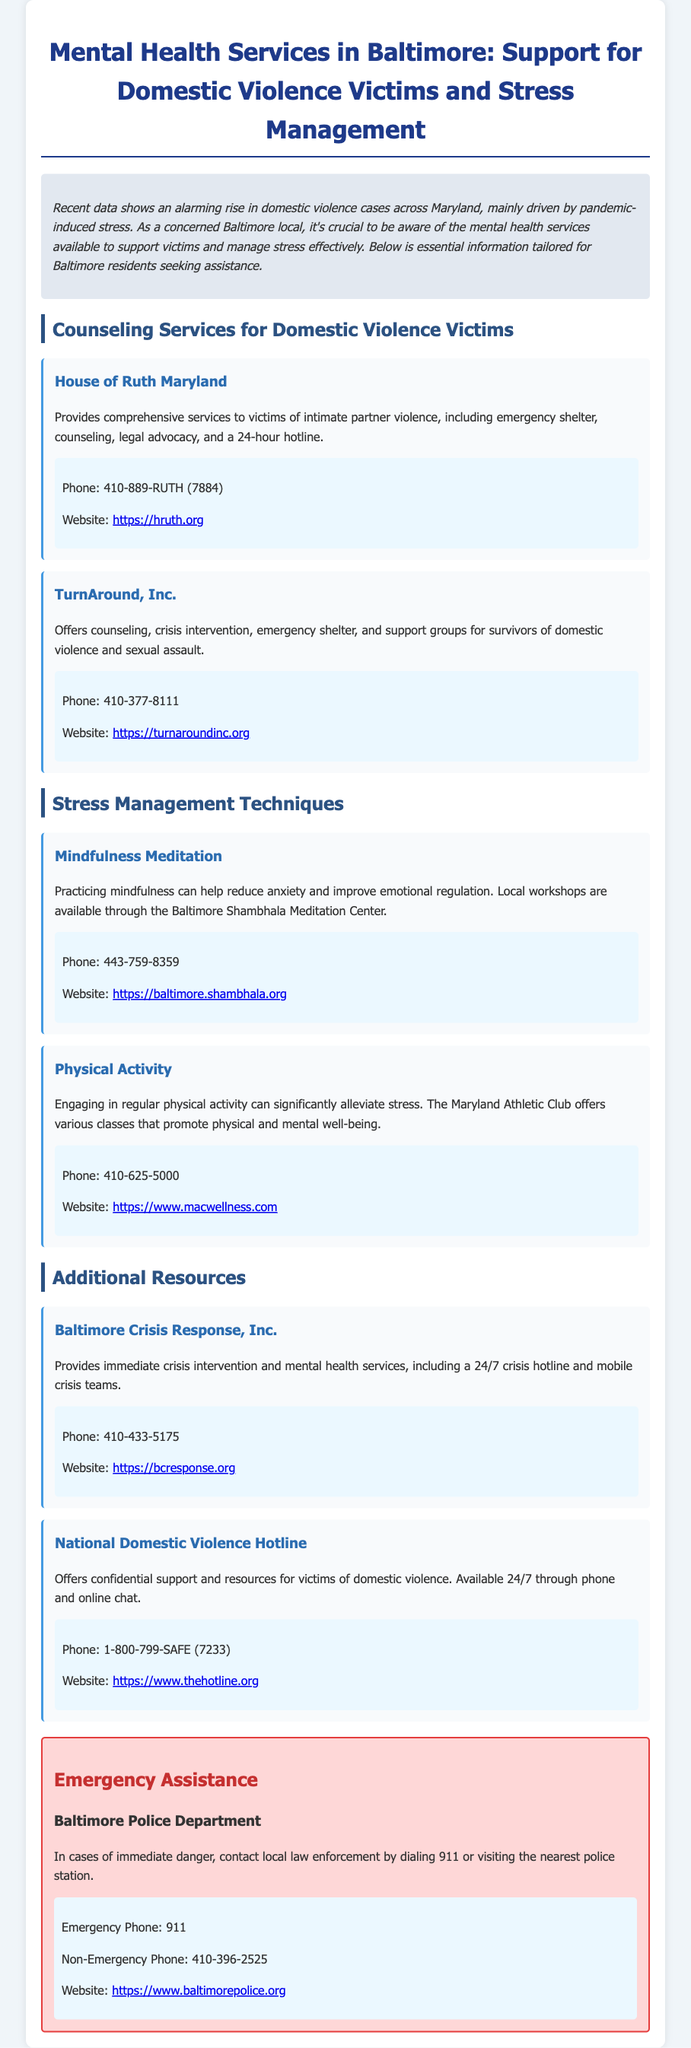What services does House of Ruth Maryland provide? House of Ruth Maryland offers comprehensive services to victims of intimate partner violence, including emergency shelter, counseling, legal advocacy, and a 24-hour hotline.
Answer: Comprehensive services What is the contact number for TurnAround, Inc.? The document lists the contact number for TurnAround, Inc. as 410-377-8111.
Answer: 410-377-8111 Which resource offers immediate crisis intervention? The resource that provides immediate crisis intervention is Baltimore Crisis Response, Inc.
Answer: Baltimore Crisis Response, Inc What technique can help reduce anxiety according to the document? The document suggests mindfulness meditation as a technique that can help reduce anxiety.
Answer: Mindfulness Meditation In what situation should you call 911? You should call 911 in cases of immediate danger.
Answer: Immediate danger What type of organizations are included in the document? The document includes counseling services, stress management techniques, and crisis intervention resources.
Answer: Organizations for counseling, stress management, and crisis intervention How can you practice physical activity for stress management? Engaging in regular physical activity can significantly alleviate stress, and classes are offered at the Maryland Athletic Club.
Answer: Maryland Athletic Club classes What does the National Domestic Violence Hotline provide? The National Domestic Violence Hotline offers confidential support and resources for victims of domestic violence.
Answer: Confidential support and resources What is the emergency phone number for Baltimore Police Department? The emergency phone number for Baltimore Police Department is 911.
Answer: 911 